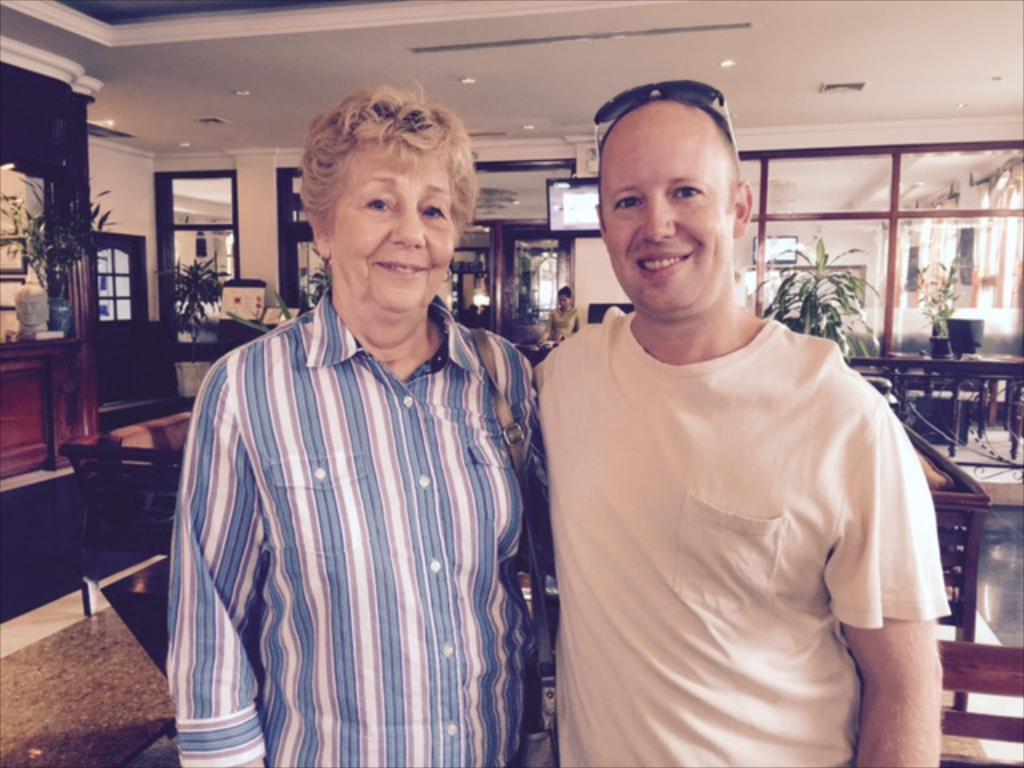Could you give a brief overview of what you see in this image? This image is clicked inside a room. There are two persons standing in the middle. There are lights at the top. There are plants in the middle. There are tables and chairs in the middle. 